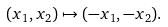Convert formula to latex. <formula><loc_0><loc_0><loc_500><loc_500>( x _ { 1 } , x _ { 2 } ) \mapsto ( - x _ { 1 } , - x _ { 2 } ) .</formula> 